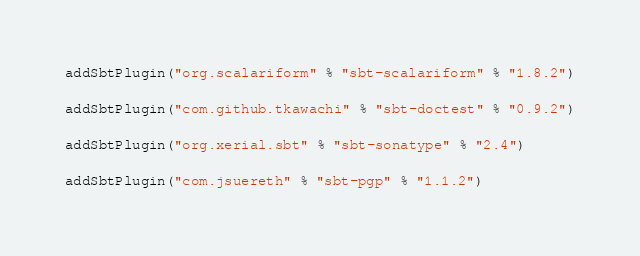Convert code to text. <code><loc_0><loc_0><loc_500><loc_500><_Scala_>addSbtPlugin("org.scalariform" % "sbt-scalariform" % "1.8.2")

addSbtPlugin("com.github.tkawachi" % "sbt-doctest" % "0.9.2")

addSbtPlugin("org.xerial.sbt" % "sbt-sonatype" % "2.4")

addSbtPlugin("com.jsuereth" % "sbt-pgp" % "1.1.2")
</code> 